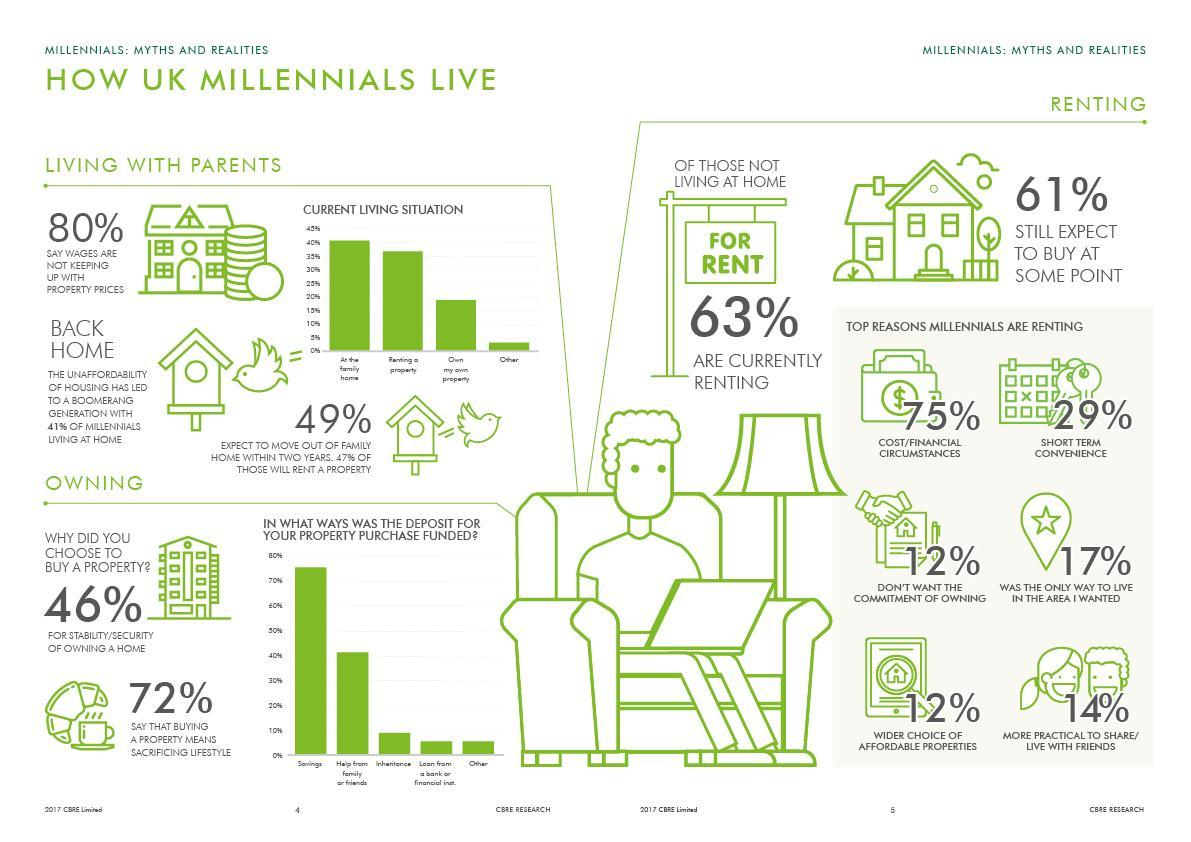What percent of people had help from family or friends to buy a property?
Answer the question with a short phrase. 40% What percent of people renting do so because that is the only way to live where they wanted to? 17% What is the most common living situation for millennials living with parents? At the family home What is the fourth top reason that millennials are renting? more practical to share/live with friends What is the second most common living situation for millennials living with parents? Renting a property What is the second top reason that millennials are renting? Short term convenience What is the top reason that millennials are renting? Cost/Financial circumstances What is the third most used way to fund for the deposit to buy property? Inheritance 